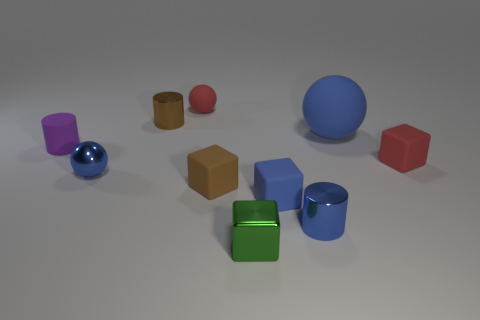Are there any big blue spheres that have the same material as the large blue object?
Offer a terse response. No. There is a cylinder that is the same color as the metal ball; what size is it?
Keep it short and to the point. Small. What is the material of the brown object behind the blue shiny object on the left side of the small blue cylinder?
Offer a very short reply. Metal. How many big matte balls have the same color as the small rubber cylinder?
Give a very brief answer. 0. What is the size of the brown thing that is made of the same material as the tiny purple thing?
Ensure brevity in your answer.  Small. What shape is the brown object that is to the right of the red ball?
Your answer should be compact. Cube. What is the size of the brown thing that is the same shape as the purple rubber thing?
Offer a very short reply. Small. How many objects are right of the small brown thing on the left side of the small red rubber thing that is behind the tiny red cube?
Give a very brief answer. 7. Is the number of small blue shiny things that are behind the blue shiny sphere the same as the number of big rubber cubes?
Your answer should be very brief. Yes. What number of cylinders are either tiny shiny objects or red things?
Provide a succinct answer. 2. 